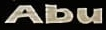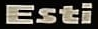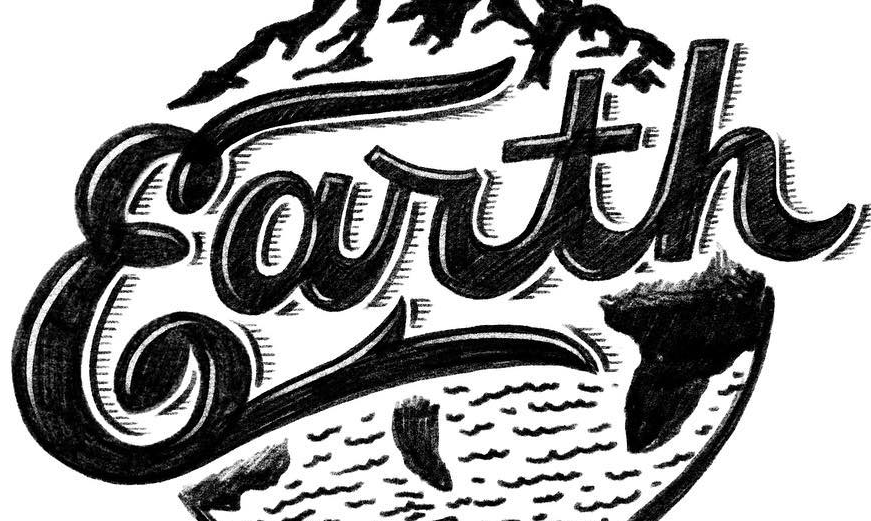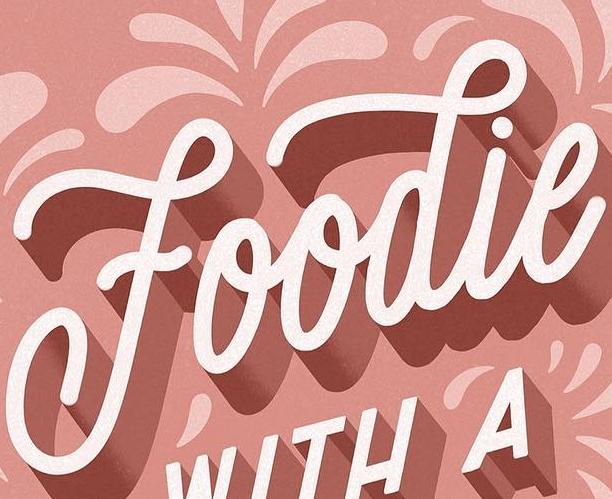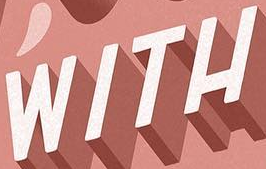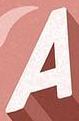What text appears in these images from left to right, separated by a semicolon? Abu; Esti; Earth; Foodie; WITH; A 